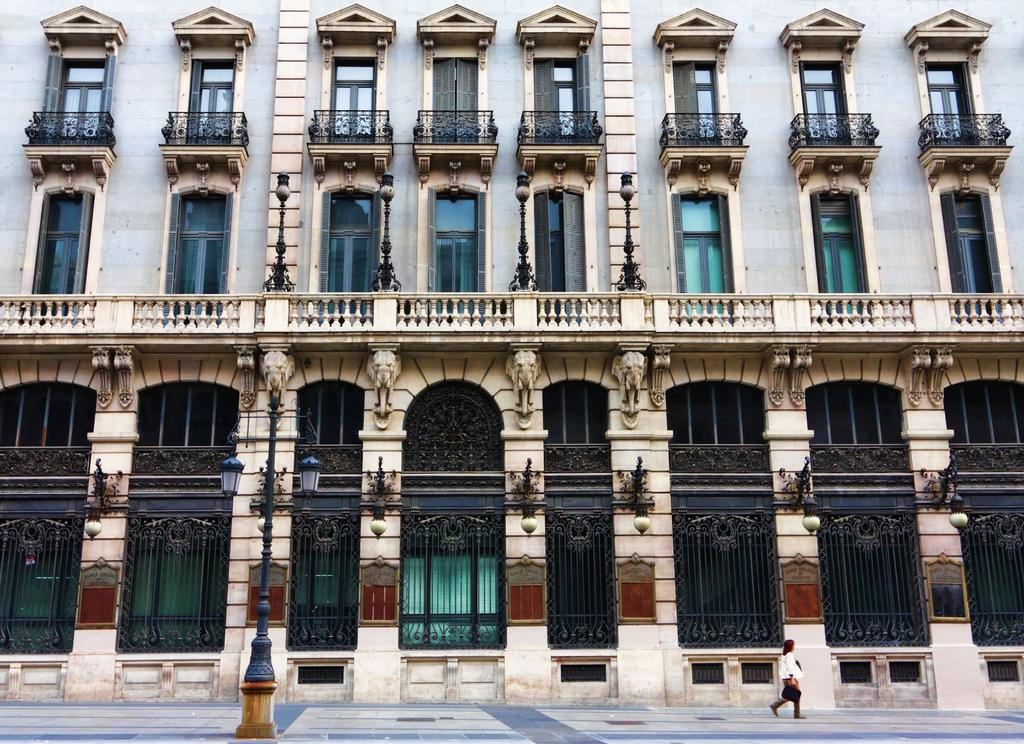What is the main structure in the picture? There is a building in the picture. What is the woman in the picture doing? A woman is walking in the picture. What type of windows does the building have? The building has glass windows. What type of rake is the woman using to make a discovery in the picture? There is no rake or discovery present in the picture; it only features a building and a woman walking. 